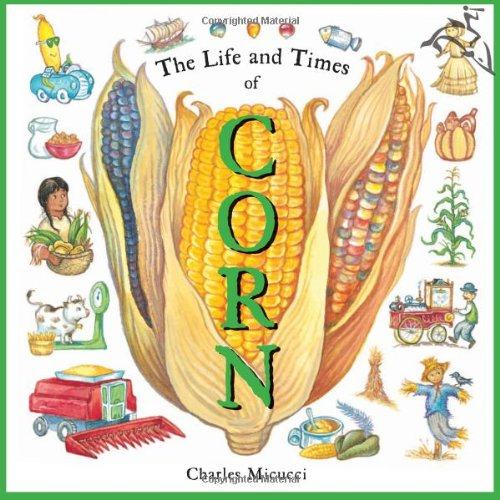Who wrote this book?
Answer the question using a single word or phrase. Charles Micucci What is the title of this book? The Life and Times of Corn What is the genre of this book? Children's Books Is this a kids book? Yes Is this a sci-fi book? No 